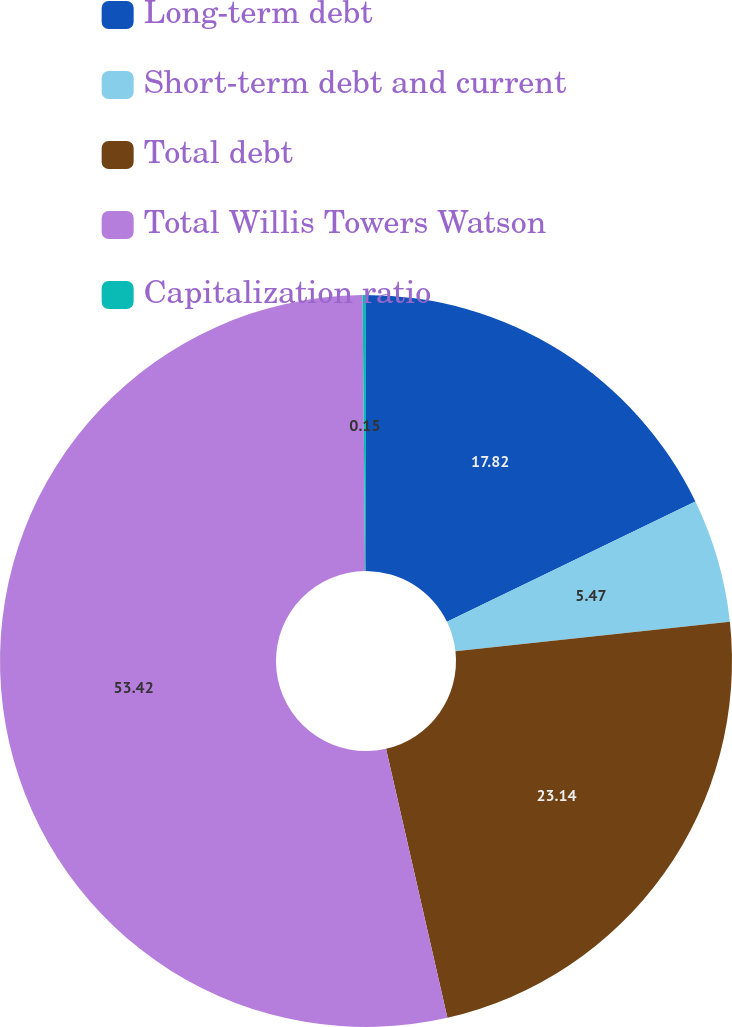Convert chart. <chart><loc_0><loc_0><loc_500><loc_500><pie_chart><fcel>Long-term debt<fcel>Short-term debt and current<fcel>Total debt<fcel>Total Willis Towers Watson<fcel>Capitalization ratio<nl><fcel>17.82%<fcel>5.47%<fcel>23.14%<fcel>53.42%<fcel>0.15%<nl></chart> 